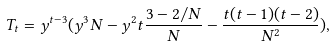Convert formula to latex. <formula><loc_0><loc_0><loc_500><loc_500>T _ { t } = y ^ { t - 3 } ( y ^ { 3 } N - y ^ { 2 } t \frac { 3 - 2 / N } { N } - \frac { t ( t - 1 ) ( t - 2 ) } { N ^ { 2 } } ) ,</formula> 